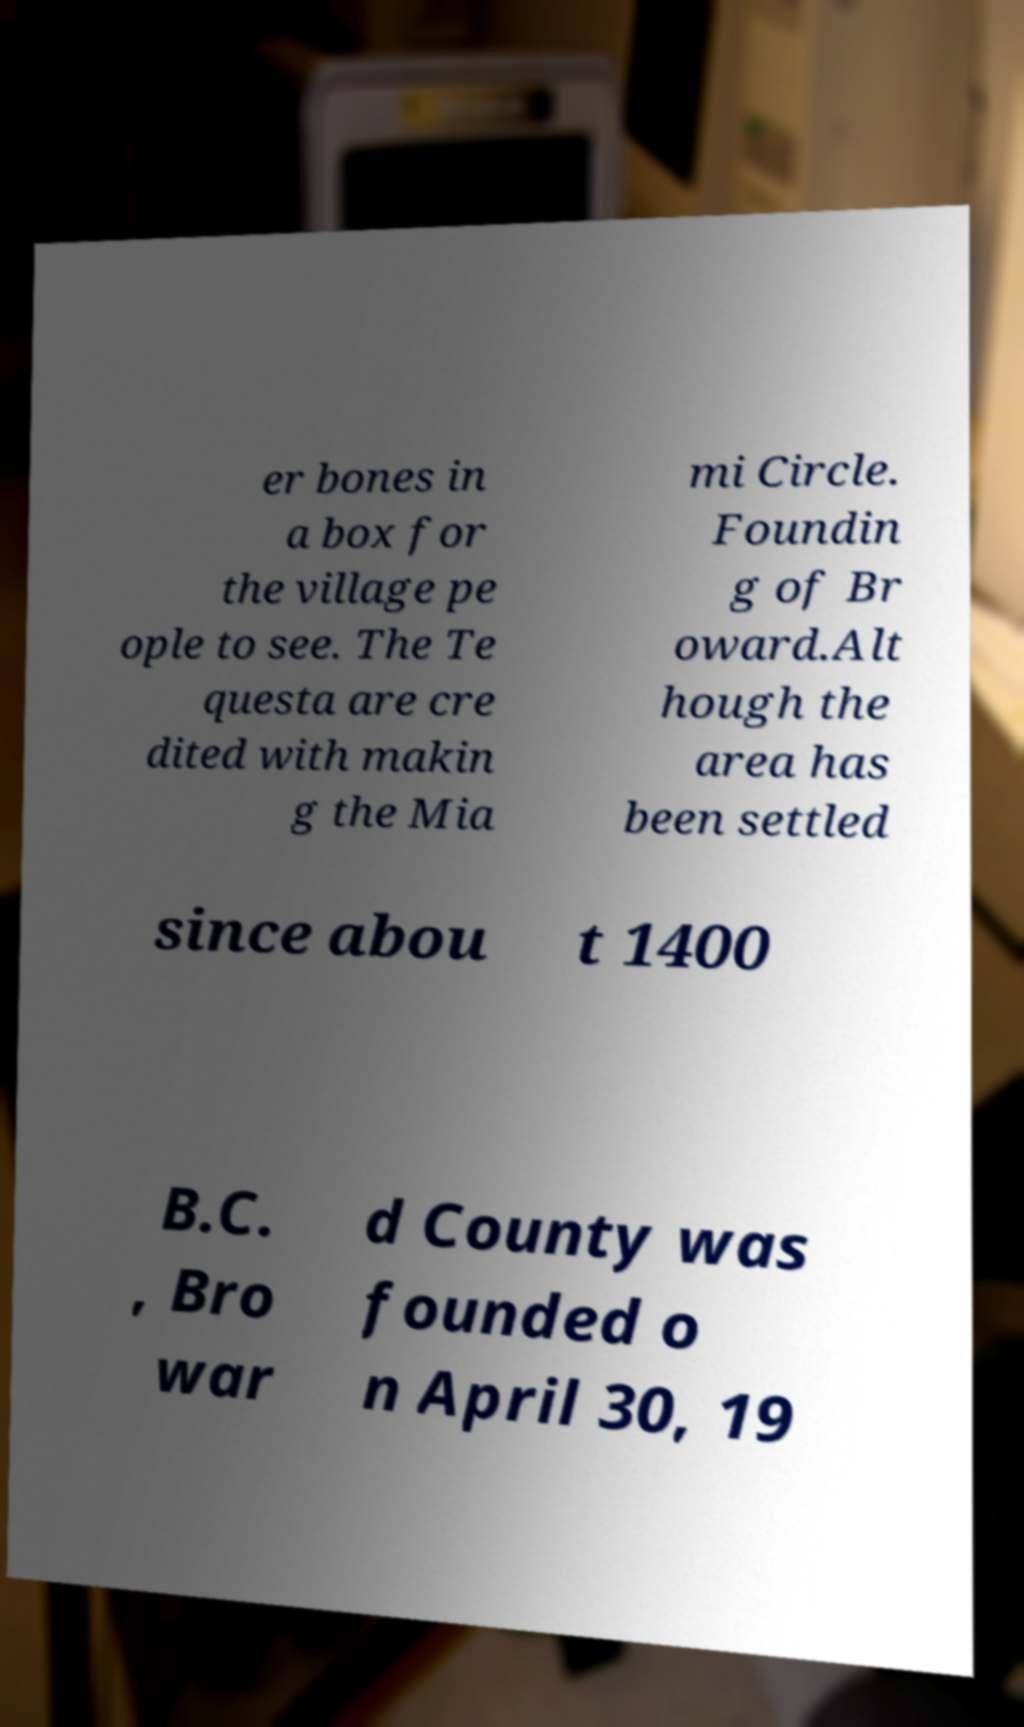Could you assist in decoding the text presented in this image and type it out clearly? er bones in a box for the village pe ople to see. The Te questa are cre dited with makin g the Mia mi Circle. Foundin g of Br oward.Alt hough the area has been settled since abou t 1400 B.C. , Bro war d County was founded o n April 30, 19 